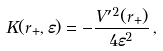Convert formula to latex. <formula><loc_0><loc_0><loc_500><loc_500>K ( r _ { + } , \varepsilon ) = - \frac { V ^ { \prime 2 } ( r _ { + } ) } { 4 \varepsilon ^ { 2 } } \, ,</formula> 